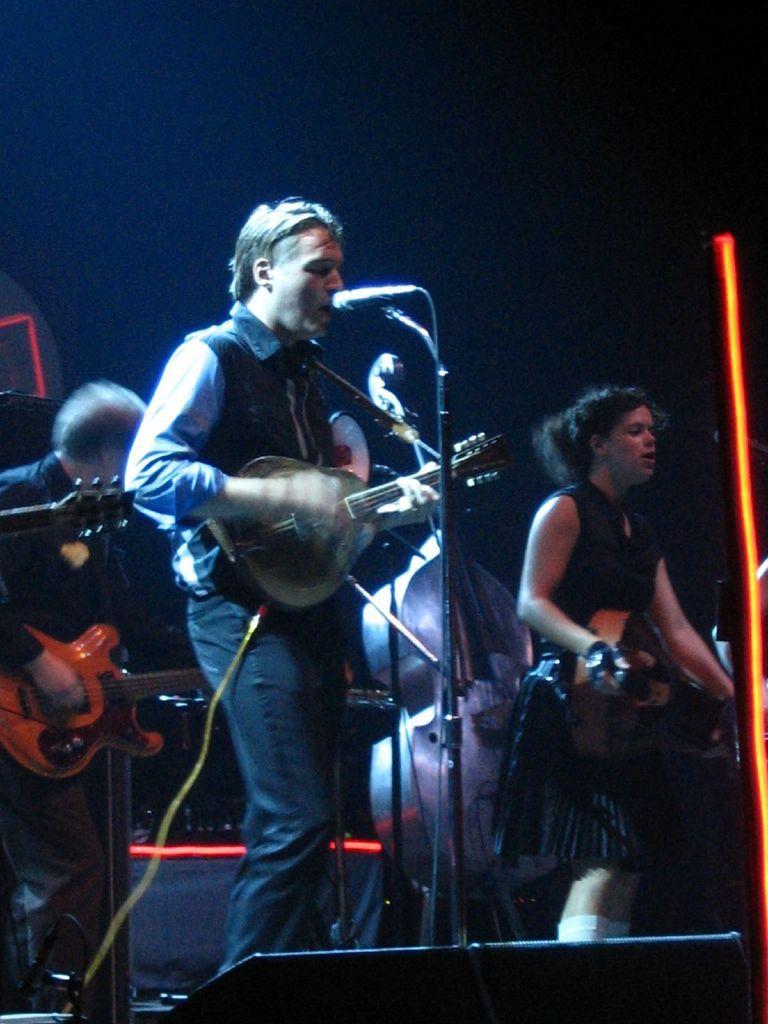How would you summarize this image in a sentence or two? In this image we have two men and one women who are playing guitar. The person in the middle is singing a song in front of the microphone on the stage. 